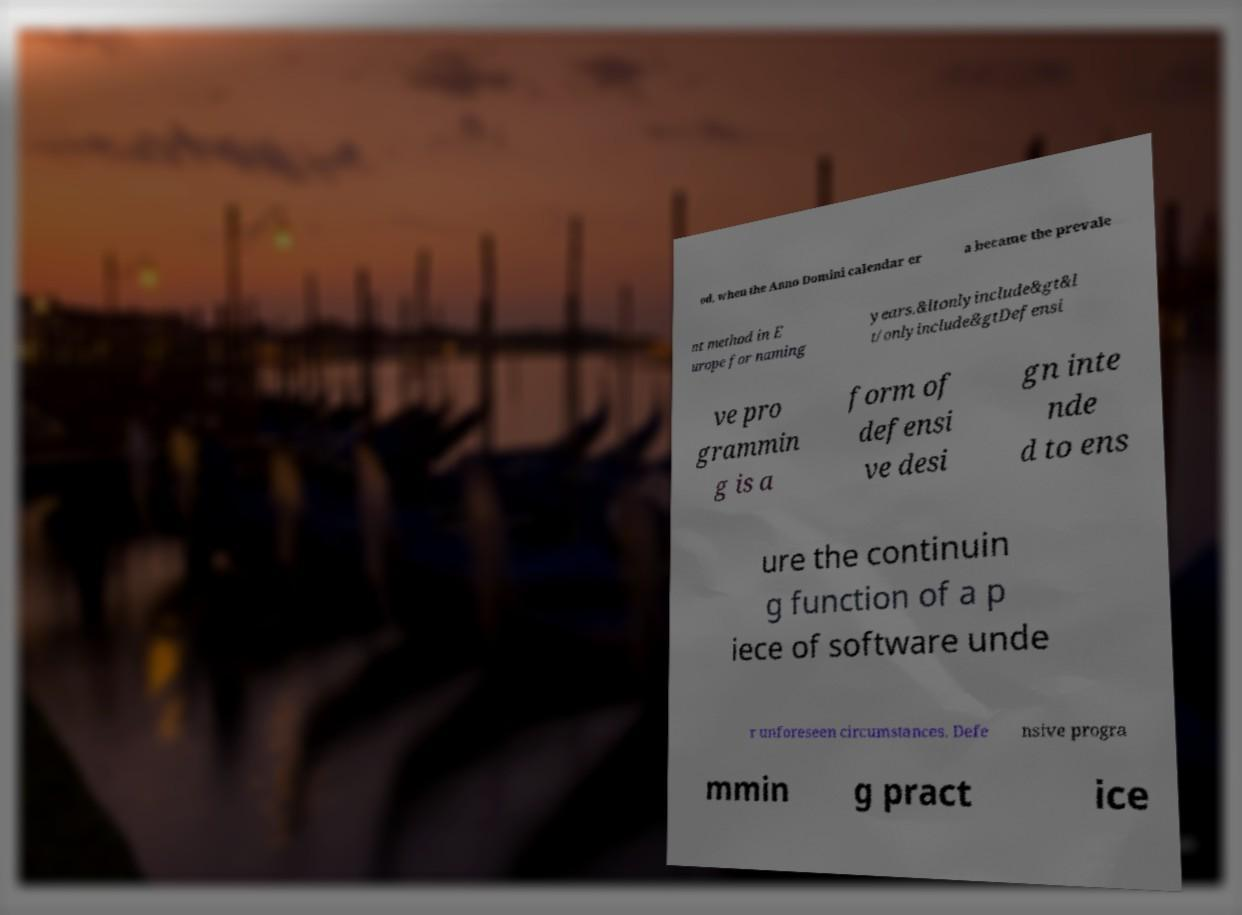What messages or text are displayed in this image? I need them in a readable, typed format. od, when the Anno Domini calendar er a became the prevale nt method in E urope for naming years.&ltonlyinclude&gt&l t/onlyinclude&gtDefensi ve pro grammin g is a form of defensi ve desi gn inte nde d to ens ure the continuin g function of a p iece of software unde r unforeseen circumstances. Defe nsive progra mmin g pract ice 